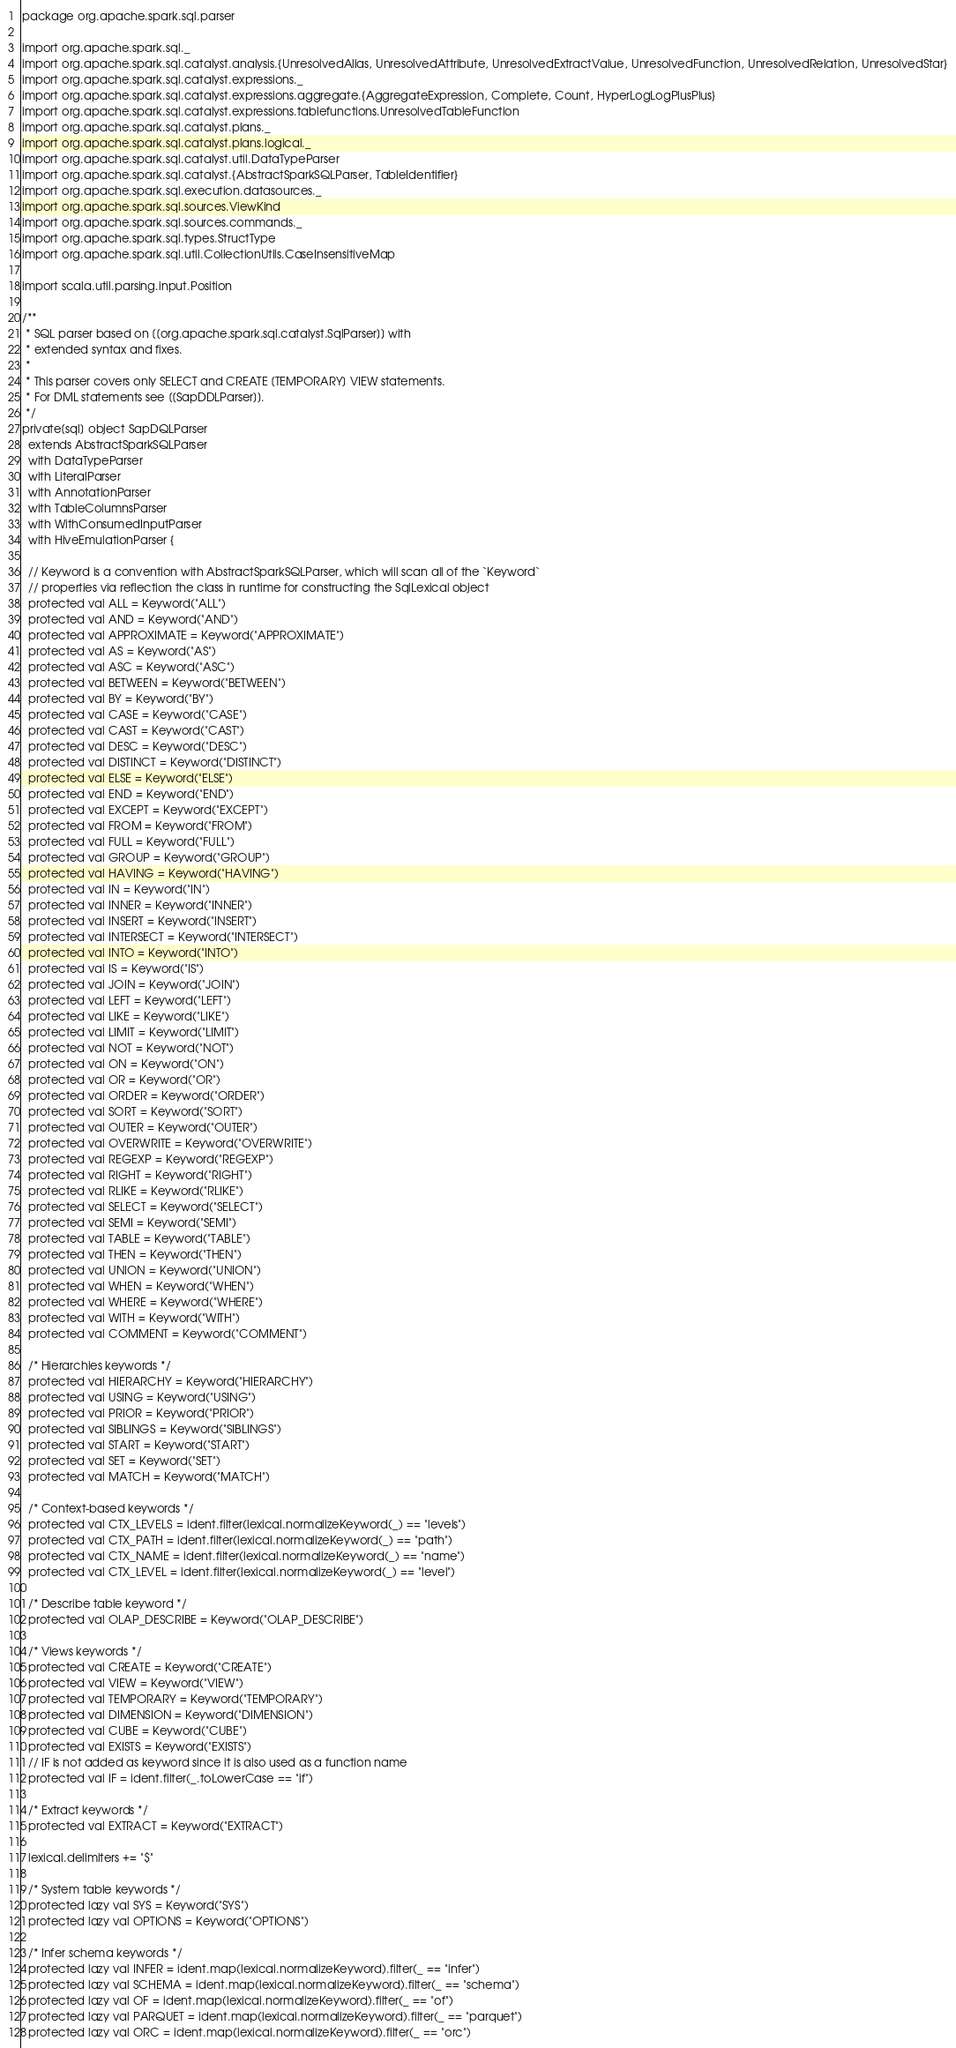<code> <loc_0><loc_0><loc_500><loc_500><_Scala_>package org.apache.spark.sql.parser

import org.apache.spark.sql._
import org.apache.spark.sql.catalyst.analysis.{UnresolvedAlias, UnresolvedAttribute, UnresolvedExtractValue, UnresolvedFunction, UnresolvedRelation, UnresolvedStar}
import org.apache.spark.sql.catalyst.expressions._
import org.apache.spark.sql.catalyst.expressions.aggregate.{AggregateExpression, Complete, Count, HyperLogLogPlusPlus}
import org.apache.spark.sql.catalyst.expressions.tablefunctions.UnresolvedTableFunction
import org.apache.spark.sql.catalyst.plans._
import org.apache.spark.sql.catalyst.plans.logical._
import org.apache.spark.sql.catalyst.util.DataTypeParser
import org.apache.spark.sql.catalyst.{AbstractSparkSQLParser, TableIdentifier}
import org.apache.spark.sql.execution.datasources._
import org.apache.spark.sql.sources.ViewKind
import org.apache.spark.sql.sources.commands._
import org.apache.spark.sql.types.StructType
import org.apache.spark.sql.util.CollectionUtils.CaseInsensitiveMap

import scala.util.parsing.input.Position

/**
 * SQL parser based on [[org.apache.spark.sql.catalyst.SqlParser]] with
 * extended syntax and fixes.
 *
 * This parser covers only SELECT and CREATE [TEMPORARY] VIEW statements.
 * For DML statements see [[SapDDLParser]].
 */
private[sql] object SapDQLParser
  extends AbstractSparkSQLParser
  with DataTypeParser
  with LiteralParser
  with AnnotationParser
  with TableColumnsParser
  with WithConsumedInputParser
  with HiveEmulationParser {

  // Keyword is a convention with AbstractSparkSQLParser, which will scan all of the `Keyword`
  // properties via reflection the class in runtime for constructing the SqlLexical object
  protected val ALL = Keyword("ALL")
  protected val AND = Keyword("AND")
  protected val APPROXIMATE = Keyword("APPROXIMATE")
  protected val AS = Keyword("AS")
  protected val ASC = Keyword("ASC")
  protected val BETWEEN = Keyword("BETWEEN")
  protected val BY = Keyword("BY")
  protected val CASE = Keyword("CASE")
  protected val CAST = Keyword("CAST")
  protected val DESC = Keyword("DESC")
  protected val DISTINCT = Keyword("DISTINCT")
  protected val ELSE = Keyword("ELSE")
  protected val END = Keyword("END")
  protected val EXCEPT = Keyword("EXCEPT")
  protected val FROM = Keyword("FROM")
  protected val FULL = Keyword("FULL")
  protected val GROUP = Keyword("GROUP")
  protected val HAVING = Keyword("HAVING")
  protected val IN = Keyword("IN")
  protected val INNER = Keyword("INNER")
  protected val INSERT = Keyword("INSERT")
  protected val INTERSECT = Keyword("INTERSECT")
  protected val INTO = Keyword("INTO")
  protected val IS = Keyword("IS")
  protected val JOIN = Keyword("JOIN")
  protected val LEFT = Keyword("LEFT")
  protected val LIKE = Keyword("LIKE")
  protected val LIMIT = Keyword("LIMIT")
  protected val NOT = Keyword("NOT")
  protected val ON = Keyword("ON")
  protected val OR = Keyword("OR")
  protected val ORDER = Keyword("ORDER")
  protected val SORT = Keyword("SORT")
  protected val OUTER = Keyword("OUTER")
  protected val OVERWRITE = Keyword("OVERWRITE")
  protected val REGEXP = Keyword("REGEXP")
  protected val RIGHT = Keyword("RIGHT")
  protected val RLIKE = Keyword("RLIKE")
  protected val SELECT = Keyword("SELECT")
  protected val SEMI = Keyword("SEMI")
  protected val TABLE = Keyword("TABLE")
  protected val THEN = Keyword("THEN")
  protected val UNION = Keyword("UNION")
  protected val WHEN = Keyword("WHEN")
  protected val WHERE = Keyword("WHERE")
  protected val WITH = Keyword("WITH")
  protected val COMMENT = Keyword("COMMENT")

  /* Hierarchies keywords */
  protected val HIERARCHY = Keyword("HIERARCHY")
  protected val USING = Keyword("USING")
  protected val PRIOR = Keyword("PRIOR")
  protected val SIBLINGS = Keyword("SIBLINGS")
  protected val START = Keyword("START")
  protected val SET = Keyword("SET")
  protected val MATCH = Keyword("MATCH")

  /* Context-based keywords */
  protected val CTX_LEVELS = ident.filter(lexical.normalizeKeyword(_) == "levels")
  protected val CTX_PATH = ident.filter(lexical.normalizeKeyword(_) == "path")
  protected val CTX_NAME = ident.filter(lexical.normalizeKeyword(_) == "name")
  protected val CTX_LEVEL = ident.filter(lexical.normalizeKeyword(_) == "level")

  /* Describe table keyword */
  protected val OLAP_DESCRIBE = Keyword("OLAP_DESCRIBE")

  /* Views keywords */
  protected val CREATE = Keyword("CREATE")
  protected val VIEW = Keyword("VIEW")
  protected val TEMPORARY = Keyword("TEMPORARY")
  protected val DIMENSION = Keyword("DIMENSION")
  protected val CUBE = Keyword("CUBE")
  protected val EXISTS = Keyword("EXISTS")
  // IF is not added as keyword since it is also used as a function name
  protected val IF = ident.filter(_.toLowerCase == "if")

  /* Extract keywords */
  protected val EXTRACT = Keyword("EXTRACT")

  lexical.delimiters += "$"

  /* System table keywords */
  protected lazy val SYS = Keyword("SYS")
  protected lazy val OPTIONS = Keyword("OPTIONS")

  /* Infer schema keywords */
  protected lazy val INFER = ident.map(lexical.normalizeKeyword).filter(_ == "infer")
  protected lazy val SCHEMA = ident.map(lexical.normalizeKeyword).filter(_ == "schema")
  protected lazy val OF = ident.map(lexical.normalizeKeyword).filter(_ == "of")
  protected lazy val PARQUET = ident.map(lexical.normalizeKeyword).filter(_ == "parquet")
  protected lazy val ORC = ident.map(lexical.normalizeKeyword).filter(_ == "orc")
</code> 